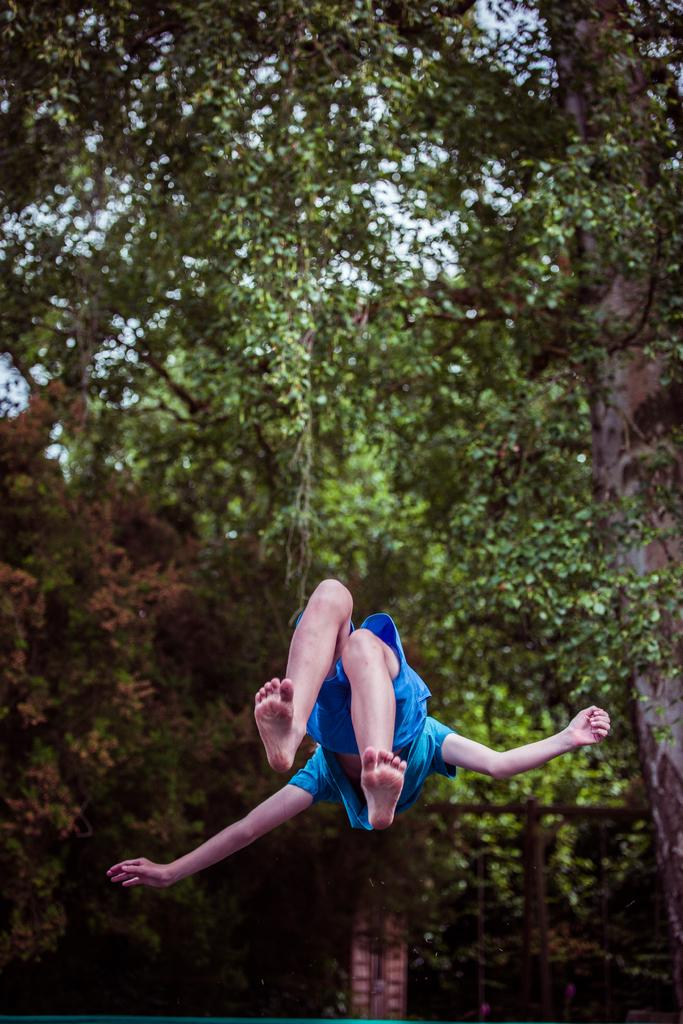Who or what is present in the image? There is a person in the image. Can you describe the position of the second person in relation to the first person? There is another person above the first person. What can be seen below the second person? The water surface is visible below the second person. What type of natural environment is visible in the background of the image? There are trees visible in the background of the image. What type of apple is being held by the person in the image? There is no apple present in the image. What are the two people talking about in the image? The image does not provide any information about what the two people might be talking about. 